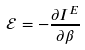<formula> <loc_0><loc_0><loc_500><loc_500>\mathcal { E } = - \frac { \partial I ^ { E } } { \partial \beta }</formula> 